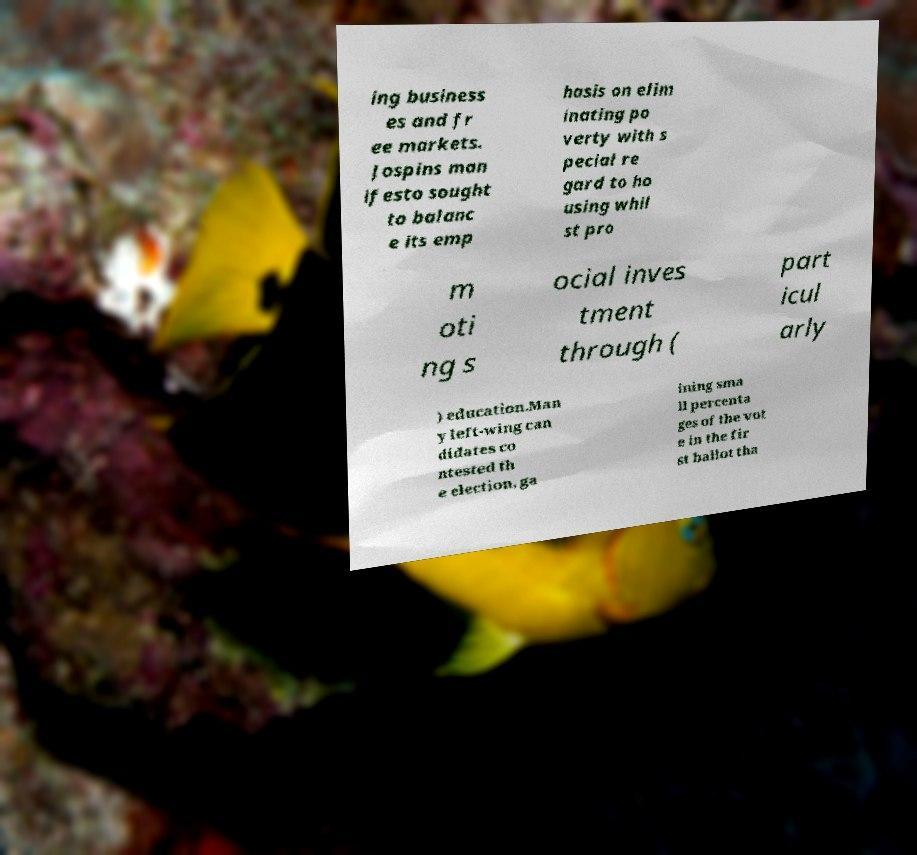I need the written content from this picture converted into text. Can you do that? ing business es and fr ee markets. Jospins man ifesto sought to balanc e its emp hasis on elim inating po verty with s pecial re gard to ho using whil st pro m oti ng s ocial inves tment through ( part icul arly ) education.Man y left-wing can didates co ntested th e election, ga ining sma ll percenta ges of the vot e in the fir st ballot tha 